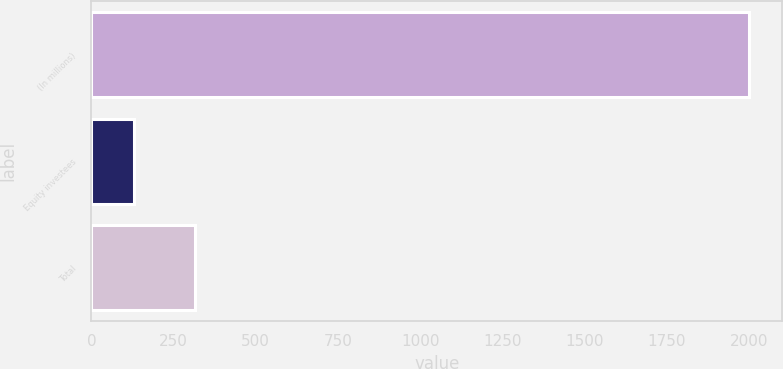Convert chart. <chart><loc_0><loc_0><loc_500><loc_500><bar_chart><fcel>(In millions)<fcel>Equity investees<fcel>Total<nl><fcel>2001<fcel>129<fcel>316.2<nl></chart> 